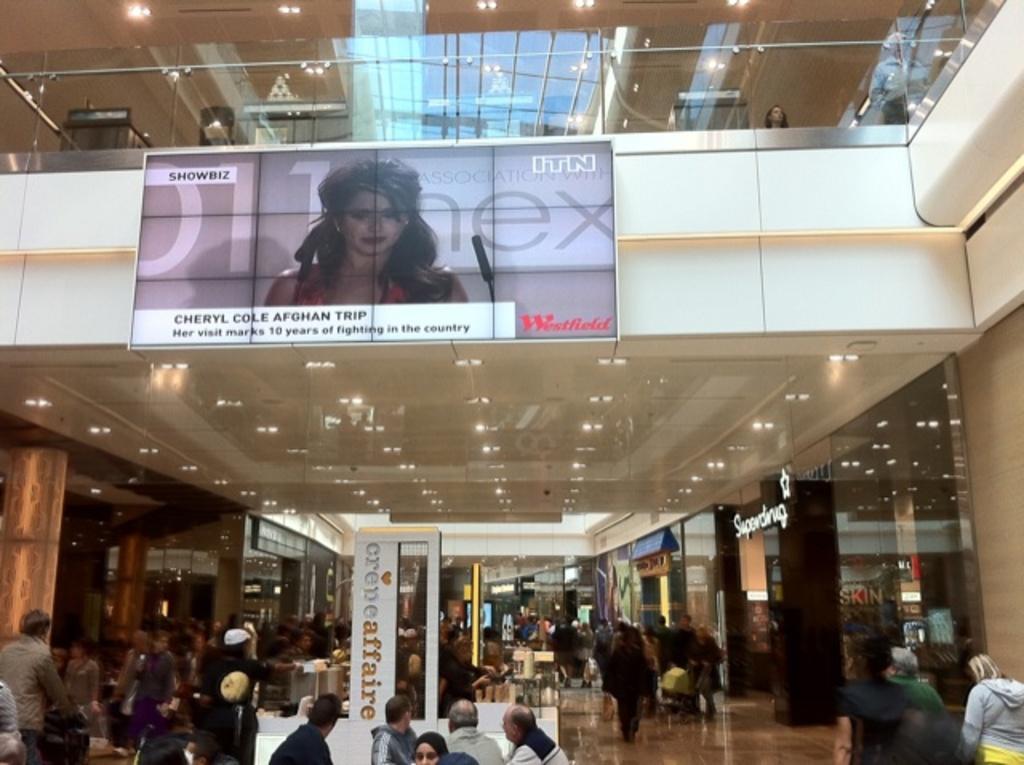Describe this image in one or two sentences. This is an inside view of a building. At the bottom of the image, we can see people, floorboards, wall, pillars and glass objects. In the middle of the image, we can see the ceiling with lights. At the top of the image, we can see glass railing, few objects, people, ceiling with lights and board on the wall. 